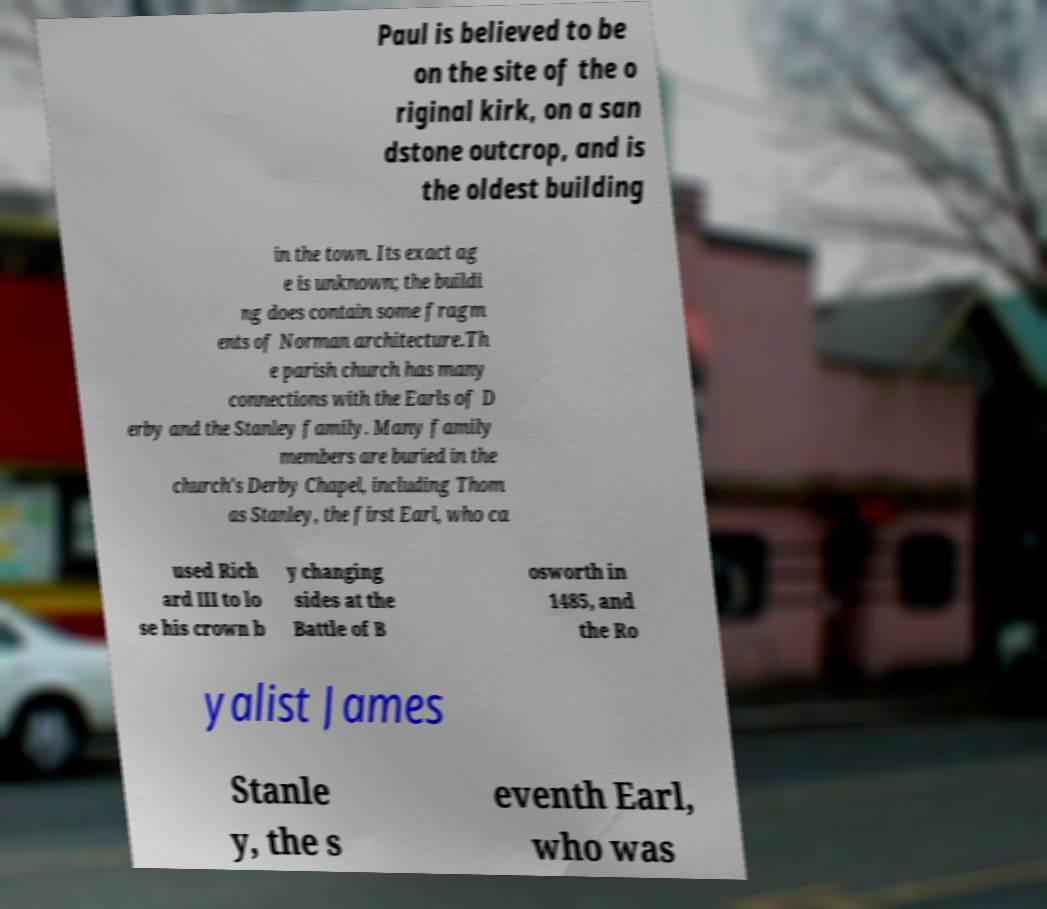Please identify and transcribe the text found in this image. Paul is believed to be on the site of the o riginal kirk, on a san dstone outcrop, and is the oldest building in the town. Its exact ag e is unknown; the buildi ng does contain some fragm ents of Norman architecture.Th e parish church has many connections with the Earls of D erby and the Stanley family. Many family members are buried in the church's Derby Chapel, including Thom as Stanley, the first Earl, who ca used Rich ard III to lo se his crown b y changing sides at the Battle of B osworth in 1485, and the Ro yalist James Stanle y, the s eventh Earl, who was 